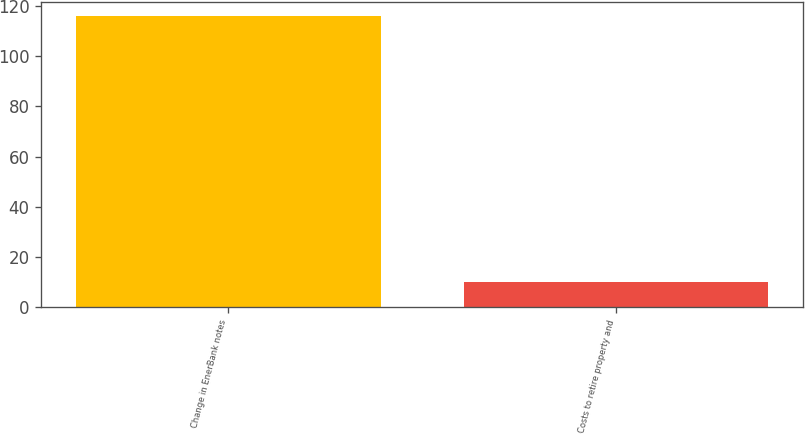Convert chart to OTSL. <chart><loc_0><loc_0><loc_500><loc_500><bar_chart><fcel>Change in EnerBank notes<fcel>Costs to retire property and<nl><fcel>116<fcel>10<nl></chart> 